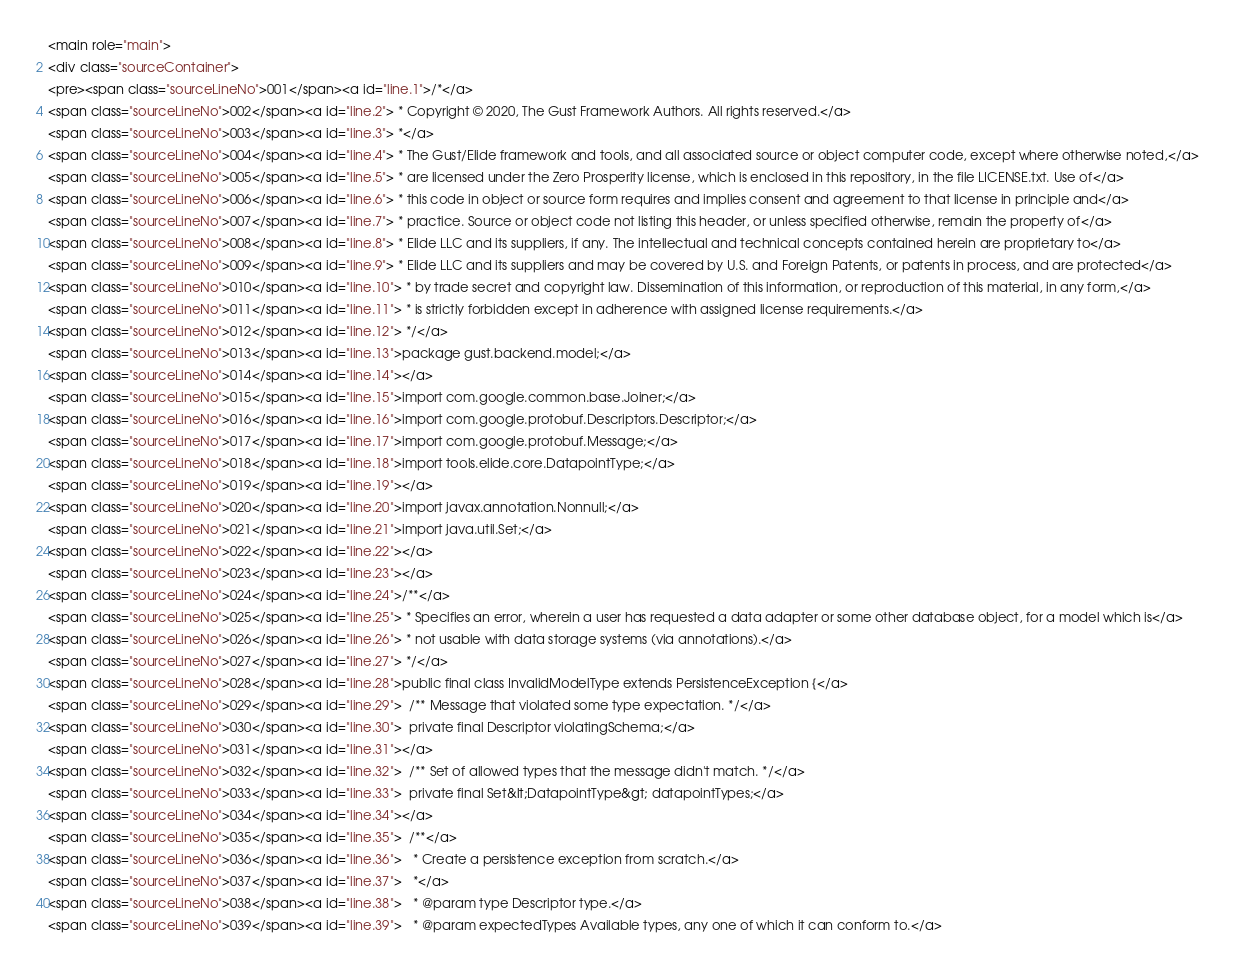<code> <loc_0><loc_0><loc_500><loc_500><_HTML_><main role="main">
<div class="sourceContainer">
<pre><span class="sourceLineNo">001</span><a id="line.1">/*</a>
<span class="sourceLineNo">002</span><a id="line.2"> * Copyright © 2020, The Gust Framework Authors. All rights reserved.</a>
<span class="sourceLineNo">003</span><a id="line.3"> *</a>
<span class="sourceLineNo">004</span><a id="line.4"> * The Gust/Elide framework and tools, and all associated source or object computer code, except where otherwise noted,</a>
<span class="sourceLineNo">005</span><a id="line.5"> * are licensed under the Zero Prosperity license, which is enclosed in this repository, in the file LICENSE.txt. Use of</a>
<span class="sourceLineNo">006</span><a id="line.6"> * this code in object or source form requires and implies consent and agreement to that license in principle and</a>
<span class="sourceLineNo">007</span><a id="line.7"> * practice. Source or object code not listing this header, or unless specified otherwise, remain the property of</a>
<span class="sourceLineNo">008</span><a id="line.8"> * Elide LLC and its suppliers, if any. The intellectual and technical concepts contained herein are proprietary to</a>
<span class="sourceLineNo">009</span><a id="line.9"> * Elide LLC and its suppliers and may be covered by U.S. and Foreign Patents, or patents in process, and are protected</a>
<span class="sourceLineNo">010</span><a id="line.10"> * by trade secret and copyright law. Dissemination of this information, or reproduction of this material, in any form,</a>
<span class="sourceLineNo">011</span><a id="line.11"> * is strictly forbidden except in adherence with assigned license requirements.</a>
<span class="sourceLineNo">012</span><a id="line.12"> */</a>
<span class="sourceLineNo">013</span><a id="line.13">package gust.backend.model;</a>
<span class="sourceLineNo">014</span><a id="line.14"></a>
<span class="sourceLineNo">015</span><a id="line.15">import com.google.common.base.Joiner;</a>
<span class="sourceLineNo">016</span><a id="line.16">import com.google.protobuf.Descriptors.Descriptor;</a>
<span class="sourceLineNo">017</span><a id="line.17">import com.google.protobuf.Message;</a>
<span class="sourceLineNo">018</span><a id="line.18">import tools.elide.core.DatapointType;</a>
<span class="sourceLineNo">019</span><a id="line.19"></a>
<span class="sourceLineNo">020</span><a id="line.20">import javax.annotation.Nonnull;</a>
<span class="sourceLineNo">021</span><a id="line.21">import java.util.Set;</a>
<span class="sourceLineNo">022</span><a id="line.22"></a>
<span class="sourceLineNo">023</span><a id="line.23"></a>
<span class="sourceLineNo">024</span><a id="line.24">/**</a>
<span class="sourceLineNo">025</span><a id="line.25"> * Specifies an error, wherein a user has requested a data adapter or some other database object, for a model which is</a>
<span class="sourceLineNo">026</span><a id="line.26"> * not usable with data storage systems (via annotations).</a>
<span class="sourceLineNo">027</span><a id="line.27"> */</a>
<span class="sourceLineNo">028</span><a id="line.28">public final class InvalidModelType extends PersistenceException {</a>
<span class="sourceLineNo">029</span><a id="line.29">  /** Message that violated some type expectation. */</a>
<span class="sourceLineNo">030</span><a id="line.30">  private final Descriptor violatingSchema;</a>
<span class="sourceLineNo">031</span><a id="line.31"></a>
<span class="sourceLineNo">032</span><a id="line.32">  /** Set of allowed types that the message didn't match. */</a>
<span class="sourceLineNo">033</span><a id="line.33">  private final Set&lt;DatapointType&gt; datapointTypes;</a>
<span class="sourceLineNo">034</span><a id="line.34"></a>
<span class="sourceLineNo">035</span><a id="line.35">  /**</a>
<span class="sourceLineNo">036</span><a id="line.36">   * Create a persistence exception from scratch.</a>
<span class="sourceLineNo">037</span><a id="line.37">   *</a>
<span class="sourceLineNo">038</span><a id="line.38">   * @param type Descriptor type.</a>
<span class="sourceLineNo">039</span><a id="line.39">   * @param expectedTypes Available types, any one of which it can conform to.</a></code> 